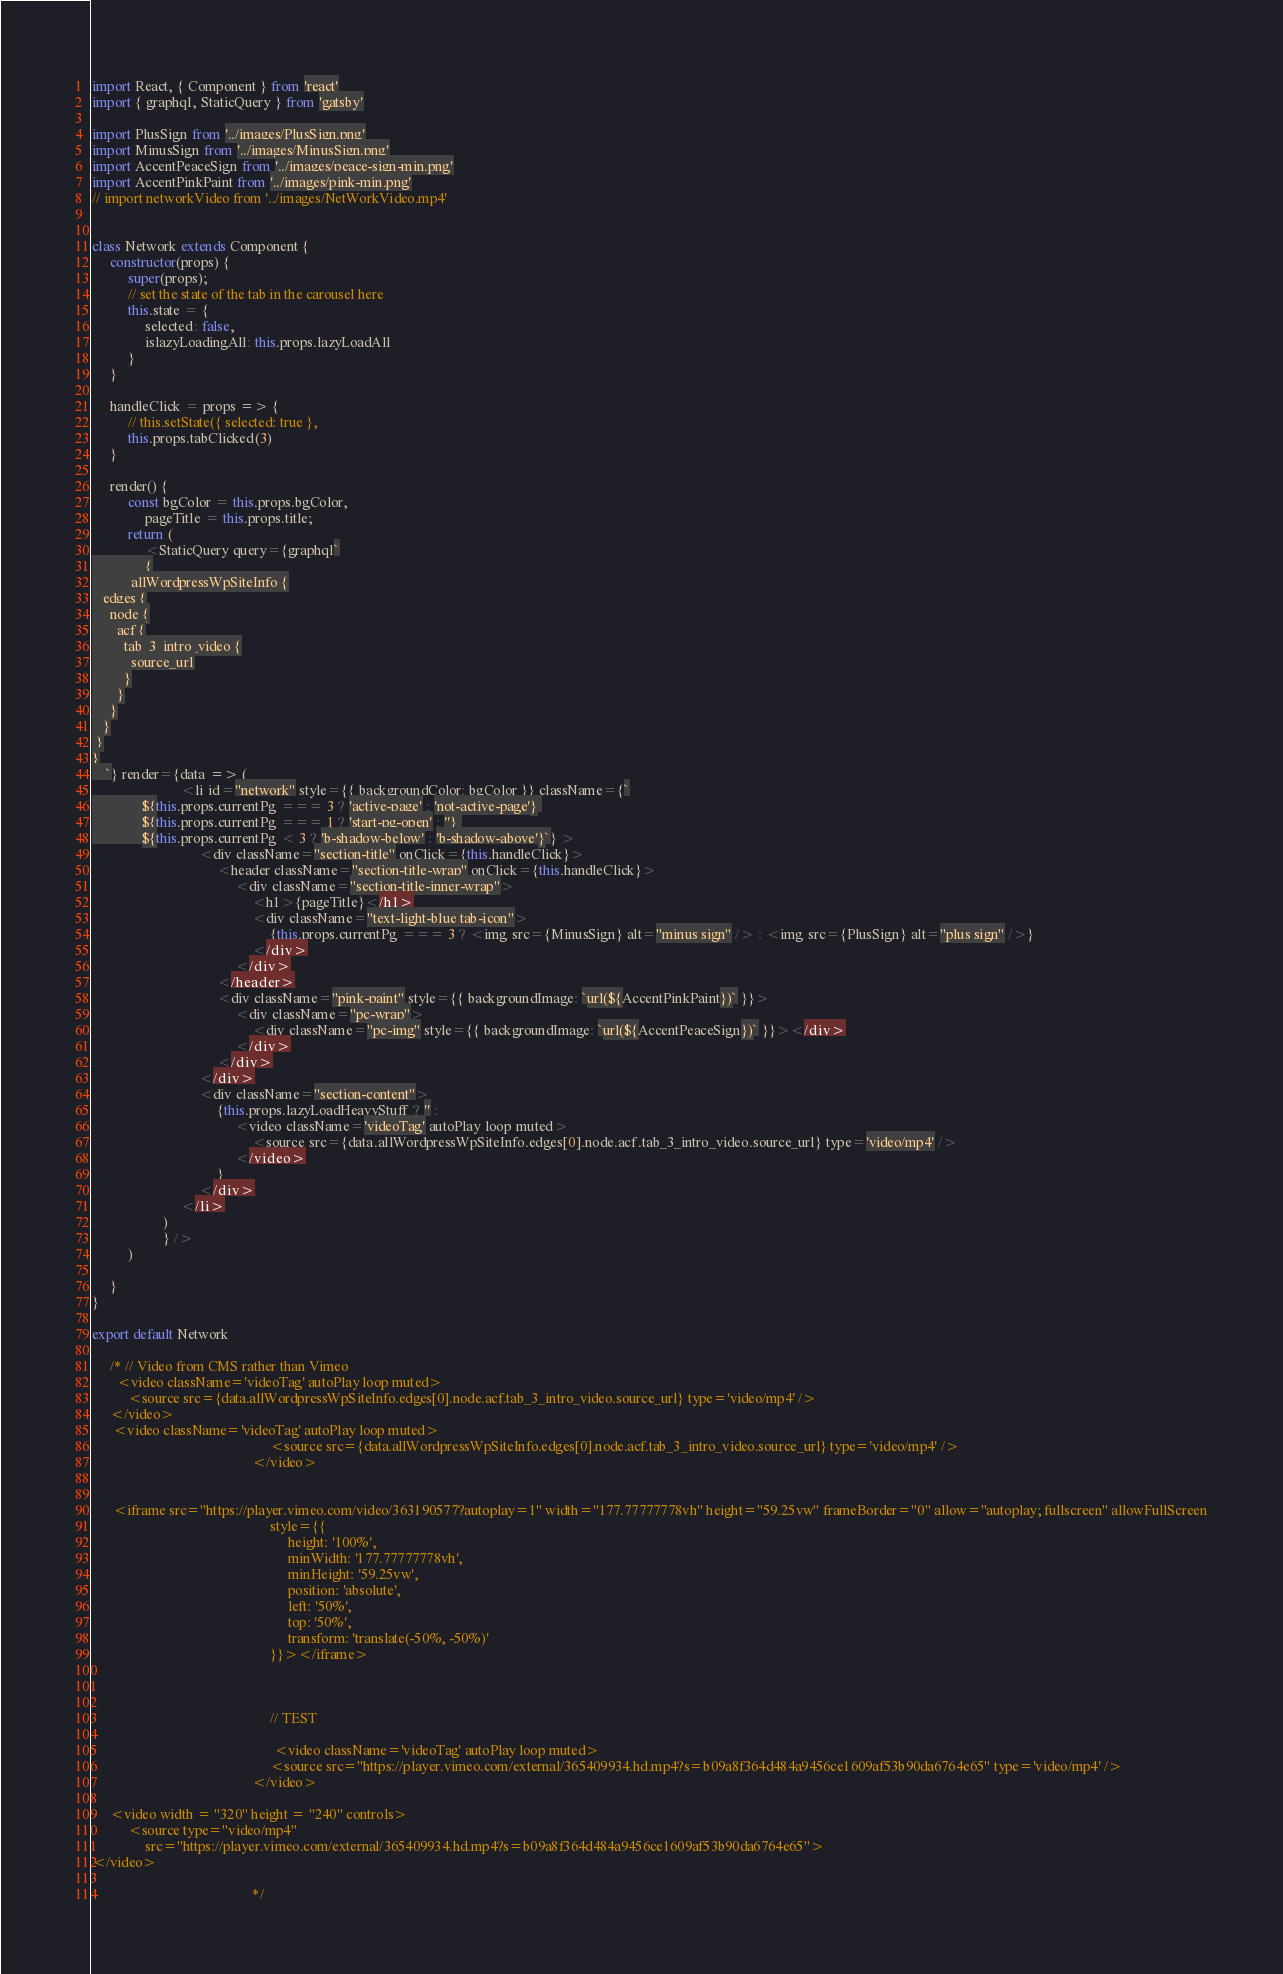Convert code to text. <code><loc_0><loc_0><loc_500><loc_500><_JavaScript_>import React, { Component } from 'react'
import { graphql, StaticQuery } from 'gatsby'

import PlusSign from '../images/PlusSign.png'
import MinusSign from '../images/MinusSign.png'
import AccentPeaceSign from '../images/peace-sign-min.png'
import AccentPinkPaint from '../images/pink-min.png'
// import networkVideo from '../images/NetWorkVideo.mp4'


class Network extends Component {
     constructor(props) {
          super(props);
          // set the state of the tab in the carousel here
          this.state = {
               selected: false,
               islazyLoadingAll: this.props.lazyLoadAll
          }
     }

     handleClick = props => {
          // this.setState({ selected: true },
          this.props.tabClicked(3)
     }

     render() {
          const bgColor = this.props.bgColor,
               pageTitle = this.props.title;
          return (
               <StaticQuery query={graphql`
               {
           allWordpressWpSiteInfo {
   edges {
     node {
       acf {
         tab_3_intro_video {
           source_url
         }
       }
     }
   }
 }
}
    `} render={data => (
                         <li id="network" style={{ backgroundColor: bgColor }} className={`
              ${this.props.currentPg === 3 ? 'active-page' : 'not-active-page'} 
              ${this.props.currentPg === 1 ? 'start-pg-open' : ''} 
              ${this.props.currentPg < 3 ? 'b-shadow-below' : 'b-shadow-above'}`} >
                              <div className="section-title" onClick={this.handleClick}>
                                   <header className="section-title-wrap" onClick={this.handleClick}>
                                        <div className="section-title-inner-wrap">
                                             <h1>{pageTitle}</h1>
                                             <div className="text-light-blue tab-icon">
                                                  {this.props.currentPg === 3 ? <img src={MinusSign} alt="minus sign" /> : <img src={PlusSign} alt="plus sign" />}
                                             </div>
                                        </div>
                                   </header>
                                   <div className="pink-paint" style={{ backgroundImage: `url(${AccentPinkPaint})` }}>
                                        <div className="pc-wrap">
                                             <div className="pc-img" style={{ backgroundImage: `url(${AccentPeaceSign})` }}></div>
                                        </div>
                                   </div>
                              </div>
                              <div className="section-content">
                                   {this.props.lazyLoadHeavyStuff ? '' :
                                        <video className='videoTag' autoPlay loop muted>
                                             <source src={data.allWordpressWpSiteInfo.edges[0].node.acf.tab_3_intro_video.source_url} type='video/mp4' />
                                        </video>
                                   }
                              </div>
                         </li>
                    )
                    } />
          )

     }
}

export default Network

     /* // Video from CMS rather than Vimeo
       <video className='videoTag' autoPlay loop muted>
          <source src={data.allWordpressWpSiteInfo.edges[0].node.acf.tab_3_intro_video.source_url} type='video/mp4' />
     </video>
      <video className='videoTag' autoPlay loop muted>
                                                  <source src={data.allWordpressWpSiteInfo.edges[0].node.acf.tab_3_intro_video.source_url} type='video/mp4' />
                                             </video>
     
     
      <iframe src="https://player.vimeo.com/video/363190577?autoplay=1" width="177.77777778vh" height="59.25vw" frameBorder="0" allow="autoplay; fullscreen" allowFullScreen
                                                  style={{
                                                       height: '100%',
                                                       minWidth: '177.77777778vh',
                                                       minHeight: '59.25vw',
                                                       position: 'absolute',
                                                       left: '50%',
                                                       top: '50%',
                                                       transform: 'translate(-50%, -50%)'
                                                  }}></iframe>
     
     
     
                                                  // TEST
     
                                                   <video className='videoTag' autoPlay loop muted>
                                                  <source src="https://player.vimeo.com/external/365409934.hd.mp4?s=b09a8f364d484a9456ce1609af53b90da6764e65" type='video/mp4' />
                                             </video>
     
     <video width = "320" height = "240" controls>
          <source type="video/mp4"
               src="https://player.vimeo.com/external/365409934.hd.mp4?s=b09a8f364d484a9456ce1609af53b90da6764e65">
</video>
     
                                             */</code> 